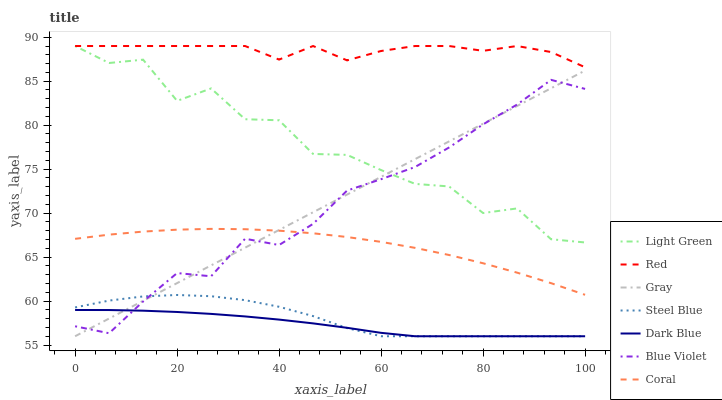Does Dark Blue have the minimum area under the curve?
Answer yes or no. Yes. Does Red have the maximum area under the curve?
Answer yes or no. Yes. Does Coral have the minimum area under the curve?
Answer yes or no. No. Does Coral have the maximum area under the curve?
Answer yes or no. No. Is Gray the smoothest?
Answer yes or no. Yes. Is Light Green the roughest?
Answer yes or no. Yes. Is Coral the smoothest?
Answer yes or no. No. Is Coral the roughest?
Answer yes or no. No. Does Gray have the lowest value?
Answer yes or no. Yes. Does Coral have the lowest value?
Answer yes or no. No. Does Light Green have the highest value?
Answer yes or no. Yes. Does Coral have the highest value?
Answer yes or no. No. Is Dark Blue less than Light Green?
Answer yes or no. Yes. Is Red greater than Gray?
Answer yes or no. Yes. Does Gray intersect Steel Blue?
Answer yes or no. Yes. Is Gray less than Steel Blue?
Answer yes or no. No. Is Gray greater than Steel Blue?
Answer yes or no. No. Does Dark Blue intersect Light Green?
Answer yes or no. No. 